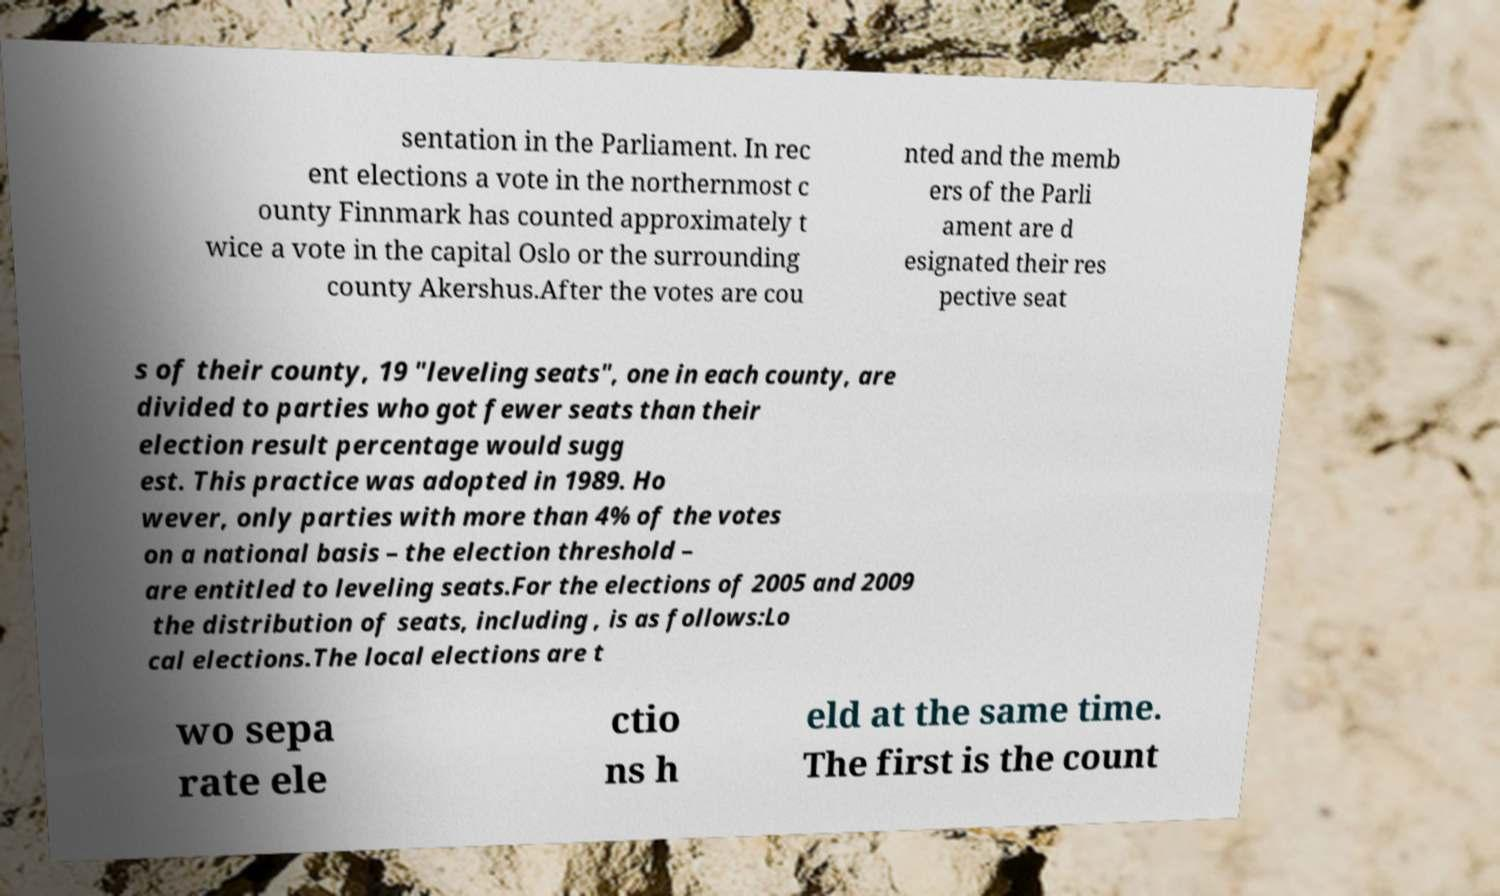For documentation purposes, I need the text within this image transcribed. Could you provide that? sentation in the Parliament. In rec ent elections a vote in the northernmost c ounty Finnmark has counted approximately t wice a vote in the capital Oslo or the surrounding county Akershus.After the votes are cou nted and the memb ers of the Parli ament are d esignated their res pective seat s of their county, 19 "leveling seats", one in each county, are divided to parties who got fewer seats than their election result percentage would sugg est. This practice was adopted in 1989. Ho wever, only parties with more than 4% of the votes on a national basis – the election threshold – are entitled to leveling seats.For the elections of 2005 and 2009 the distribution of seats, including , is as follows:Lo cal elections.The local elections are t wo sepa rate ele ctio ns h eld at the same time. The first is the count 